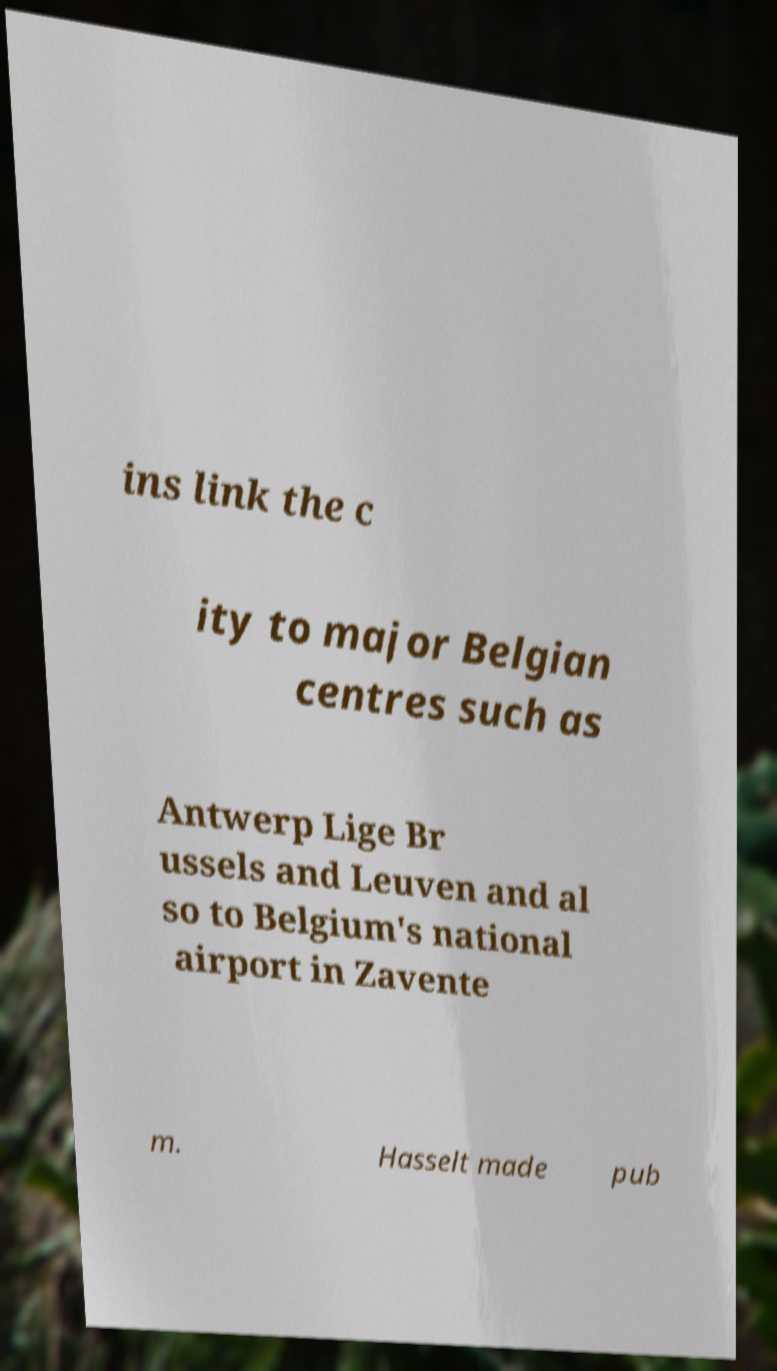Please read and relay the text visible in this image. What does it say? ins link the c ity to major Belgian centres such as Antwerp Lige Br ussels and Leuven and al so to Belgium's national airport in Zavente m. Hasselt made pub 